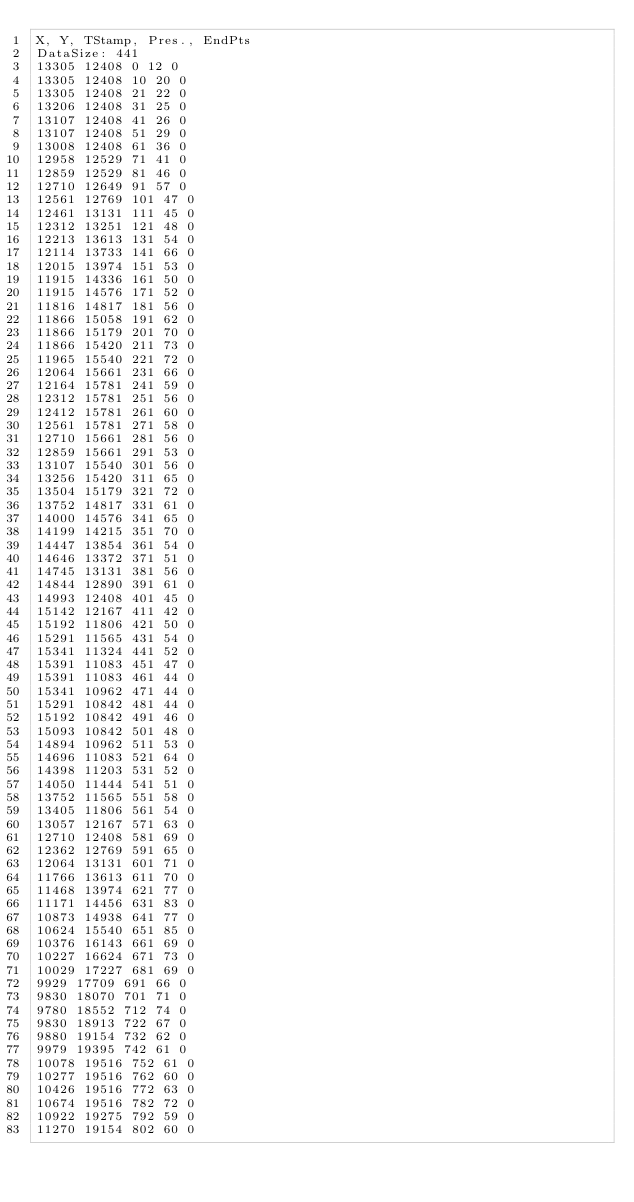Convert code to text. <code><loc_0><loc_0><loc_500><loc_500><_SML_>X, Y, TStamp, Pres., EndPts
DataSize: 441
13305 12408 0 12 0
13305 12408 10 20 0
13305 12408 21 22 0
13206 12408 31 25 0
13107 12408 41 26 0
13107 12408 51 29 0
13008 12408 61 36 0
12958 12529 71 41 0
12859 12529 81 46 0
12710 12649 91 57 0
12561 12769 101 47 0
12461 13131 111 45 0
12312 13251 121 48 0
12213 13613 131 54 0
12114 13733 141 66 0
12015 13974 151 53 0
11915 14336 161 50 0
11915 14576 171 52 0
11816 14817 181 56 0
11866 15058 191 62 0
11866 15179 201 70 0
11866 15420 211 73 0
11965 15540 221 72 0
12064 15661 231 66 0
12164 15781 241 59 0
12312 15781 251 56 0
12412 15781 261 60 0
12561 15781 271 58 0
12710 15661 281 56 0
12859 15661 291 53 0
13107 15540 301 56 0
13256 15420 311 65 0
13504 15179 321 72 0
13752 14817 331 61 0
14000 14576 341 65 0
14199 14215 351 70 0
14447 13854 361 54 0
14646 13372 371 51 0
14745 13131 381 56 0
14844 12890 391 61 0
14993 12408 401 45 0
15142 12167 411 42 0
15192 11806 421 50 0
15291 11565 431 54 0
15341 11324 441 52 0
15391 11083 451 47 0
15391 11083 461 44 0
15341 10962 471 44 0
15291 10842 481 44 0
15192 10842 491 46 0
15093 10842 501 48 0
14894 10962 511 53 0
14696 11083 521 64 0
14398 11203 531 52 0
14050 11444 541 51 0
13752 11565 551 58 0
13405 11806 561 54 0
13057 12167 571 63 0
12710 12408 581 69 0
12362 12769 591 65 0
12064 13131 601 71 0
11766 13613 611 70 0
11468 13974 621 77 0
11171 14456 631 83 0
10873 14938 641 77 0
10624 15540 651 85 0
10376 16143 661 69 0
10227 16624 671 73 0
10029 17227 681 69 0
9929 17709 691 66 0
9830 18070 701 71 0
9780 18552 712 74 0
9830 18913 722 67 0
9880 19154 732 62 0
9979 19395 742 61 0
10078 19516 752 61 0
10277 19516 762 60 0
10426 19516 772 63 0
10674 19516 782 72 0
10922 19275 792 59 0
11270 19154 802 60 0</code> 